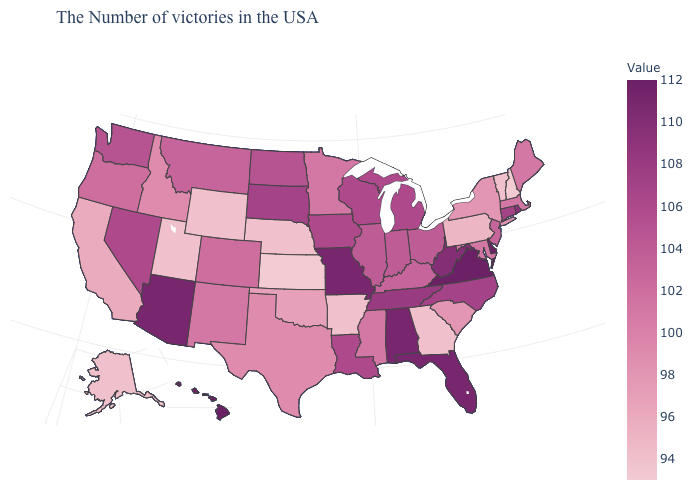Among the states that border Mississippi , does Arkansas have the highest value?
Concise answer only. No. Is the legend a continuous bar?
Quick response, please. Yes. Does New Mexico have the highest value in the USA?
Write a very short answer. No. Among the states that border North Carolina , which have the lowest value?
Answer briefly. Georgia. Which states have the highest value in the USA?
Answer briefly. Delaware, Virginia, Hawaii. Does Alaska have the lowest value in the West?
Quick response, please. Yes. 